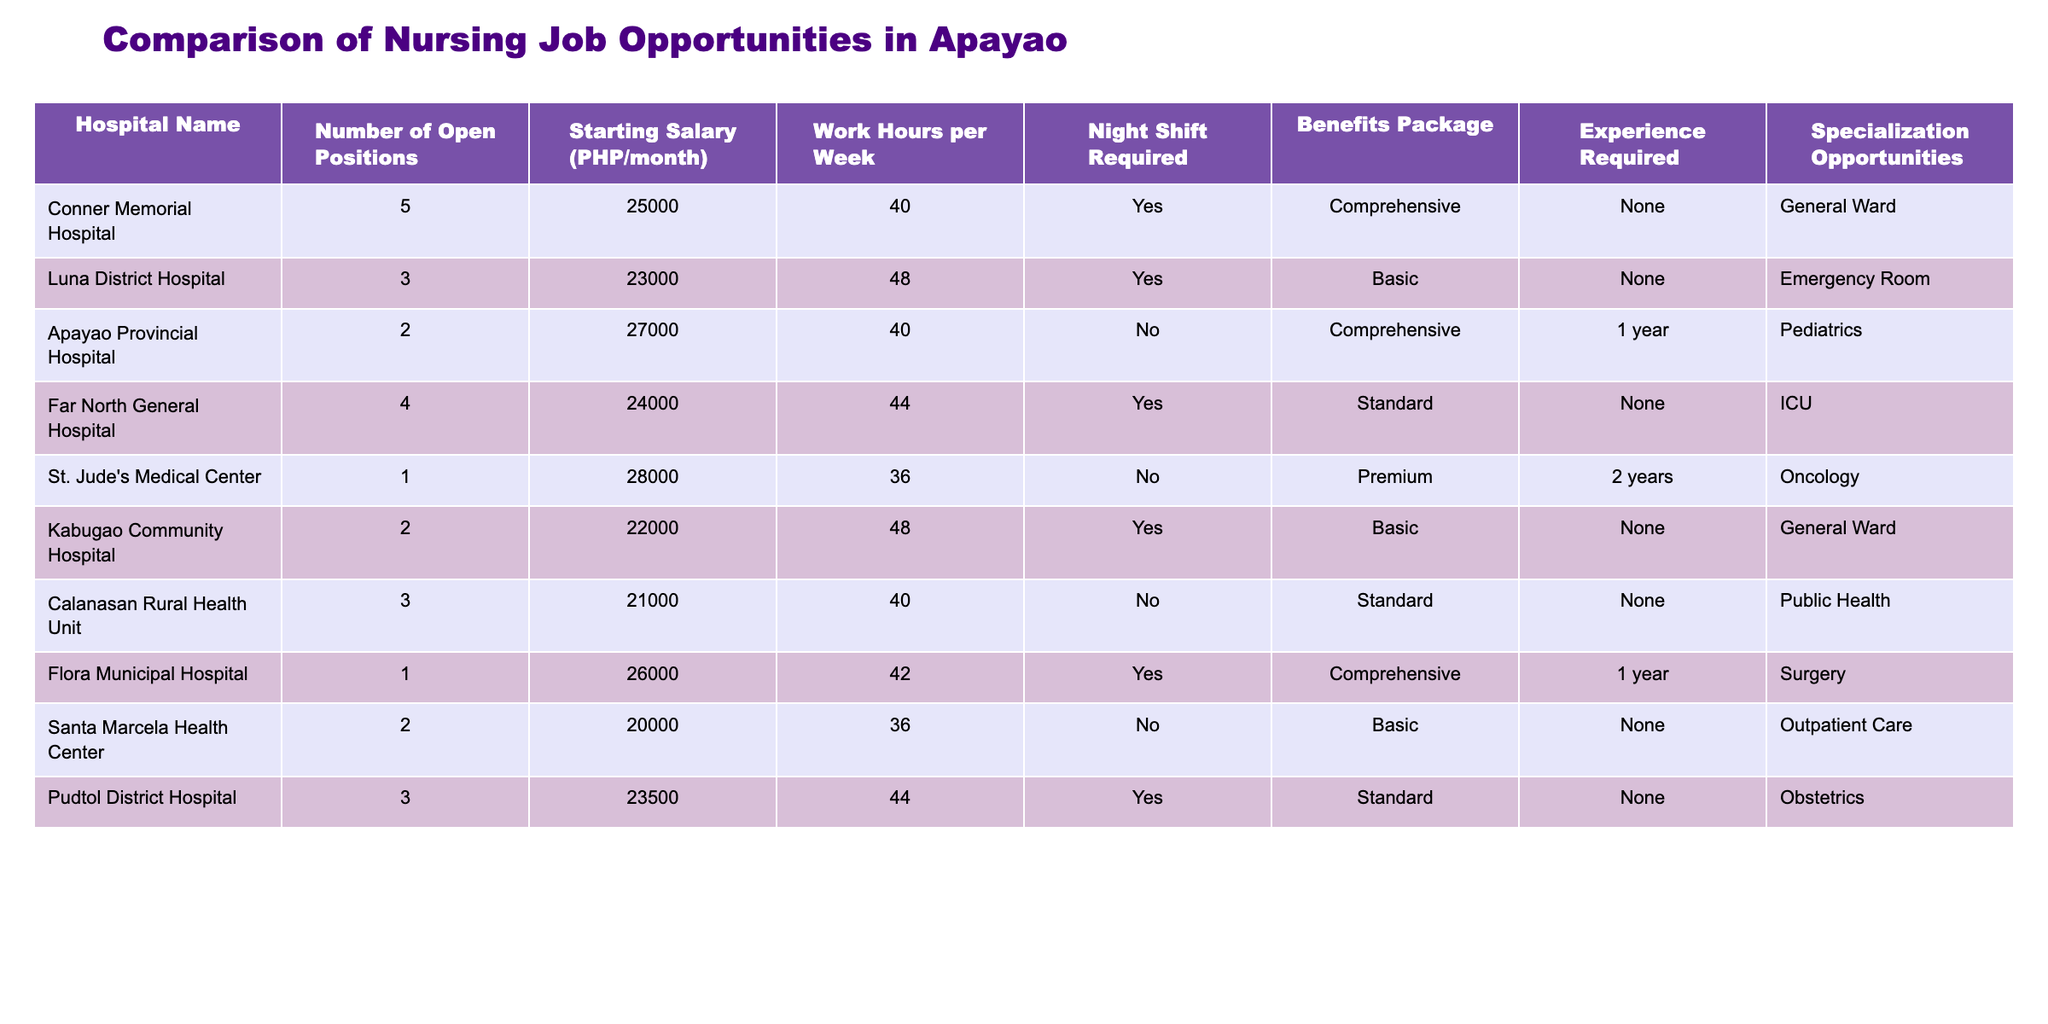What is the starting salary for a nurse at St. Jude's Medical Center? According to the table, the starting salary listed for St. Jude's Medical Center is PHP 28000 per month.
Answer: 28000 How many open positions are available at Apayao Provincial Hospital? The table indicates that Apayao Provincial Hospital has 2 open positions for nursing jobs.
Answer: 2 Which hospital offers the highest starting salary? Looking at the "Starting Salary" column, St. Jude's Medical Center offers the highest starting salary of PHP 28000.
Answer: St. Jude's Medical Center What is the average number of open positions across all hospitals? To find the average, sum up all open positions (5 + 3 + 2 + 4 + 1 + 2 + 3 + 1 + 2 + 3 = 26) and divide by the total number of hospitals (10). Thus, the average is 26/10 = 2.6.
Answer: 2.6 Is night shift required at Luna District Hospital? According to the table, Luna District Hospital does require night shifts for its nursing positions, which is marked as "Yes."
Answer: Yes How many hospitals require at least one year of experience? Scanning through the "Experience Required" column, only Apayao Provincial Hospital and Flora Municipal Hospital require 1 year of experience, making it a total of 2 hospitals.
Answer: 2 What are the benefits packages offered at hospitals that do not require experience? From the table, hospitals that do not require experience are Luna District Hospital, Far North General Hospital, Kabugao Community Hospital, Calanasan Rural Health Unit, Santa Marcela Health Center, and Pudtol District Hospital. The benefits are Basic for Luna District Hospital, Far North General Hospital, Kabugao Community Hospital, Pudtol District Hospital; and Standard for Calanasan Rural Health Unit. Therefore, the offers include Basic and Standard benefits packages.
Answer: Basic and Standard Which hospital provides specialization opportunities in Pediatrics? The table shows that only Apayao Provincial Hospital offers specialization opportunities specifically in Pediatrics.
Answer: Apayao Provincial Hospital Are there any hospitals offering more than 4 open positions? By reviewing the "Number of Open Positions" column, Conner Memorial Hospital has 5 open positions, which is more than 4. Therefore, yes, there is at least one hospital that offers more than 4 open positions.
Answer: Yes 